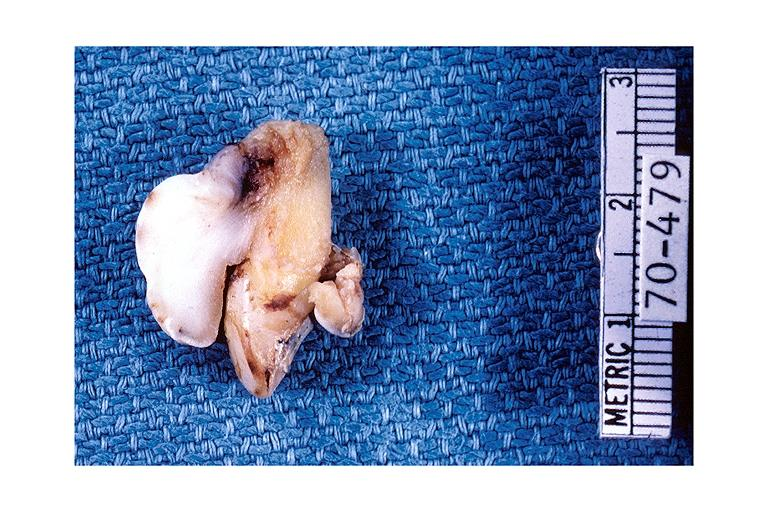what is present?
Answer the question using a single word or phrase. Oral 